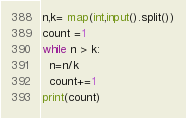Convert code to text. <code><loc_0><loc_0><loc_500><loc_500><_Python_>n,k= map(int,input().split())
count =1
while n > k:
  n=n/k
  count+=1
print(count)</code> 